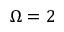<formula> <loc_0><loc_0><loc_500><loc_500>\Omega = 2</formula> 